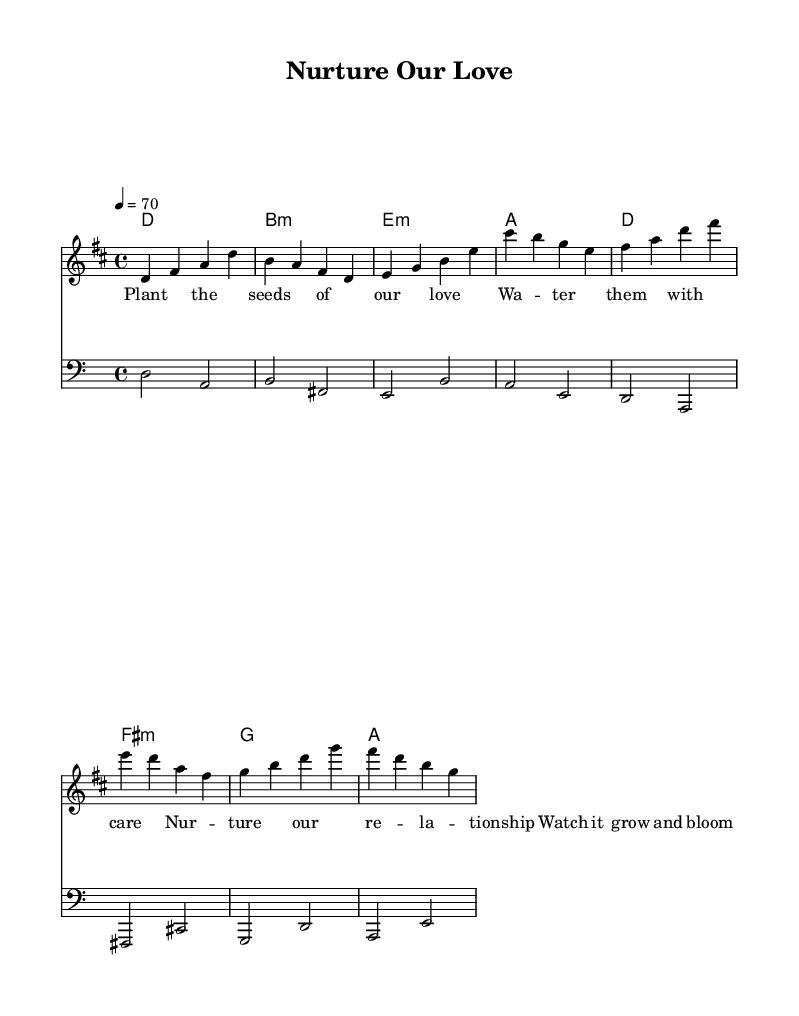What is the key signature of this music? The key signature is indicated at the beginning of the staff and shows two sharps. This corresponds to the key of D major.
Answer: D major What is the time signature of this music? The time signature is located at the beginning of the staff, indicating how many beats are in each measure. The '4/4' indicates there are four beats per measure, with each beat being a quarter note long.
Answer: 4/4 What is the tempo marking for this piece? The tempo marking is shown near the beginning and indicates the speed of the music. In this case, it is set to a quarter note equals 70 beats per minute, which means a moderate pace.
Answer: 70 How many measures are in this section of the music? By counting each distinct group of vertical lines (bar lines) that separate the measures, there are eight measures given in the melody, harmonies, and bass sections.
Answer: Eight What is the main theme of the lyrics? The lyrics metaphorically compare nurturing a relationship to taking care of plants, suggesting love should be cultivated and cared for, similar to how one would water and nurture plants.
Answer: Nurturing love How does the chord progression start in this piece? The chord progression begins with a D major chord as shown in the harmonies section, followed by a B minor chord in the next measure. This indicates the start of the harmonic structure supporting the melody.
Answer: D major What type of relationship do the lyrics of this song represent? The lyrics illustrate a romantic relationship, comparing the nurturing and care needed in love to that of cultivating plants, emphasizing growth and blooming together.
Answer: Romantic relationship 